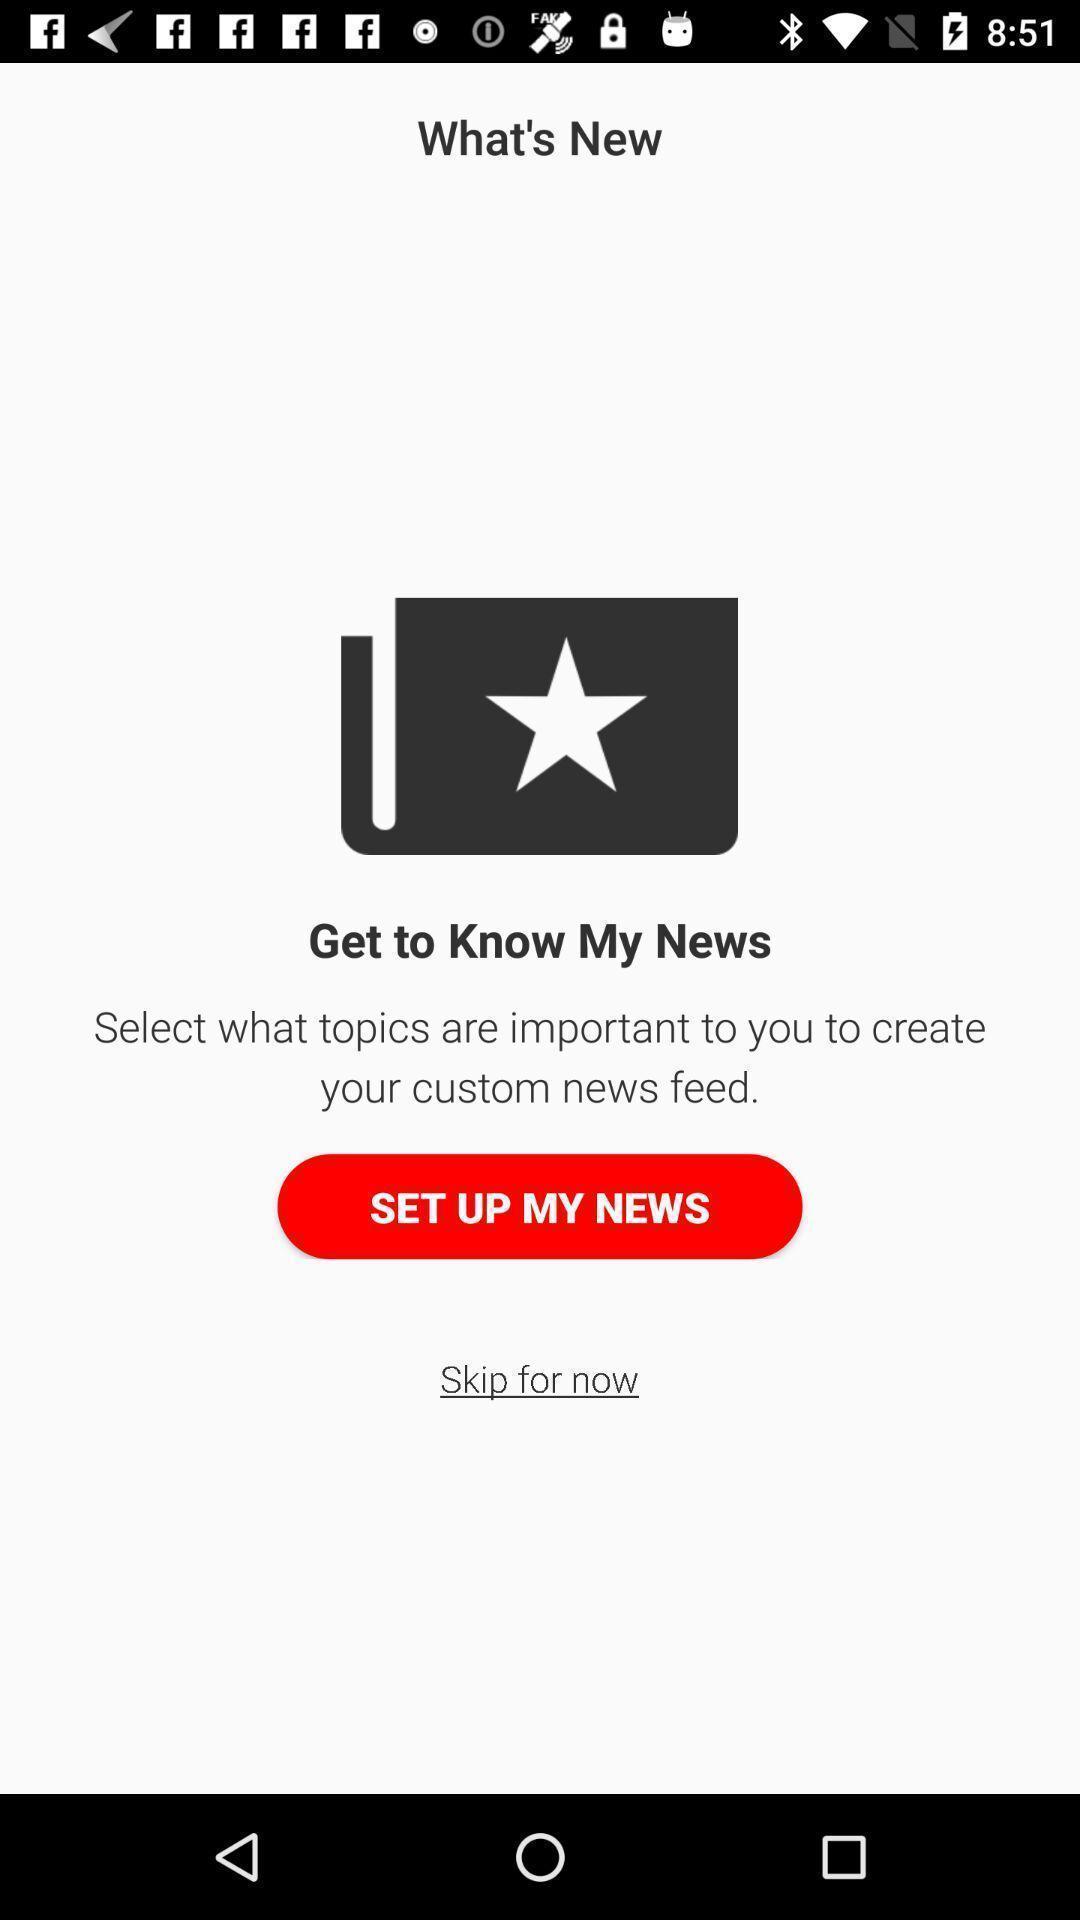Explain what's happening in this screen capture. Screen shows set up news in news app. 